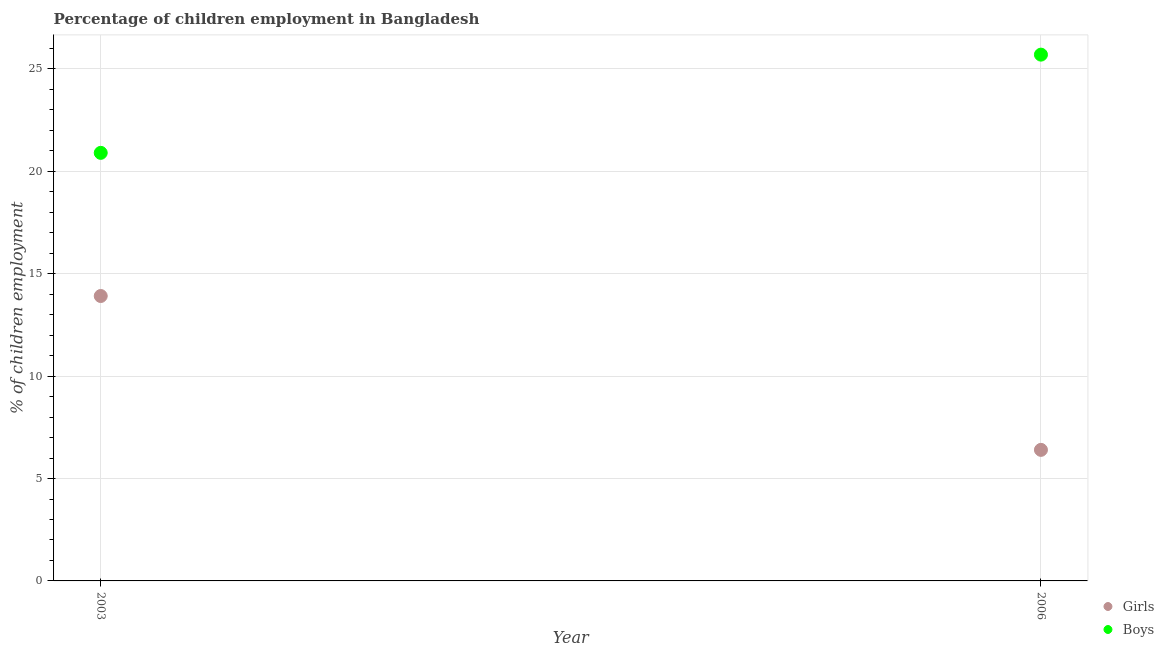What is the percentage of employed girls in 2003?
Provide a succinct answer. 13.91. Across all years, what is the maximum percentage of employed boys?
Offer a very short reply. 25.7. Across all years, what is the minimum percentage of employed girls?
Provide a succinct answer. 6.4. What is the total percentage of employed girls in the graph?
Offer a very short reply. 20.31. What is the difference between the percentage of employed girls in 2003 and that in 2006?
Your answer should be very brief. 7.51. What is the difference between the percentage of employed girls in 2003 and the percentage of employed boys in 2006?
Provide a short and direct response. -11.79. What is the average percentage of employed girls per year?
Give a very brief answer. 10.16. In the year 2003, what is the difference between the percentage of employed boys and percentage of employed girls?
Provide a short and direct response. 6.99. What is the ratio of the percentage of employed boys in 2003 to that in 2006?
Offer a very short reply. 0.81. In how many years, is the percentage of employed boys greater than the average percentage of employed boys taken over all years?
Your answer should be very brief. 1. Is the percentage of employed boys strictly greater than the percentage of employed girls over the years?
Offer a terse response. Yes. Is the percentage of employed girls strictly less than the percentage of employed boys over the years?
Give a very brief answer. Yes. How many years are there in the graph?
Make the answer very short. 2. Are the values on the major ticks of Y-axis written in scientific E-notation?
Your answer should be very brief. No. Does the graph contain grids?
Offer a terse response. Yes. How many legend labels are there?
Offer a very short reply. 2. How are the legend labels stacked?
Your response must be concise. Vertical. What is the title of the graph?
Provide a succinct answer. Percentage of children employment in Bangladesh. Does "Urban" appear as one of the legend labels in the graph?
Ensure brevity in your answer.  No. What is the label or title of the X-axis?
Your response must be concise. Year. What is the label or title of the Y-axis?
Give a very brief answer. % of children employment. What is the % of children employment of Girls in 2003?
Ensure brevity in your answer.  13.91. What is the % of children employment in Boys in 2003?
Your answer should be compact. 20.9. What is the % of children employment in Boys in 2006?
Make the answer very short. 25.7. Across all years, what is the maximum % of children employment of Girls?
Offer a terse response. 13.91. Across all years, what is the maximum % of children employment of Boys?
Offer a terse response. 25.7. Across all years, what is the minimum % of children employment of Boys?
Your answer should be very brief. 20.9. What is the total % of children employment of Girls in the graph?
Provide a short and direct response. 20.31. What is the total % of children employment of Boys in the graph?
Make the answer very short. 46.6. What is the difference between the % of children employment in Girls in 2003 and that in 2006?
Your answer should be compact. 7.51. What is the difference between the % of children employment in Boys in 2003 and that in 2006?
Give a very brief answer. -4.8. What is the difference between the % of children employment of Girls in 2003 and the % of children employment of Boys in 2006?
Your answer should be compact. -11.79. What is the average % of children employment in Girls per year?
Your answer should be compact. 10.16. What is the average % of children employment in Boys per year?
Offer a very short reply. 23.3. In the year 2003, what is the difference between the % of children employment in Girls and % of children employment in Boys?
Your response must be concise. -6.99. In the year 2006, what is the difference between the % of children employment of Girls and % of children employment of Boys?
Your answer should be compact. -19.3. What is the ratio of the % of children employment in Girls in 2003 to that in 2006?
Offer a terse response. 2.17. What is the ratio of the % of children employment in Boys in 2003 to that in 2006?
Your response must be concise. 0.81. What is the difference between the highest and the second highest % of children employment of Girls?
Offer a very short reply. 7.51. What is the difference between the highest and the second highest % of children employment in Boys?
Your response must be concise. 4.8. What is the difference between the highest and the lowest % of children employment of Girls?
Make the answer very short. 7.51. What is the difference between the highest and the lowest % of children employment of Boys?
Your answer should be compact. 4.8. 